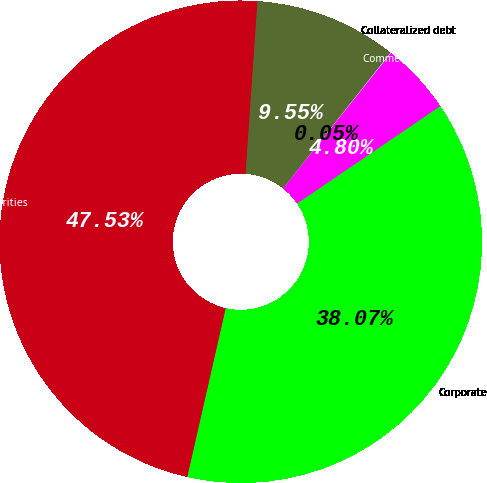Convert chart to OTSL. <chart><loc_0><loc_0><loc_500><loc_500><pie_chart><fcel>Corporate<fcel>Commercial mortgage-backed<fcel>Collateralized debt<fcel>Other debt obligations<fcel>Total fixed maturities<nl><fcel>38.07%<fcel>4.8%<fcel>0.05%<fcel>9.55%<fcel>47.53%<nl></chart> 